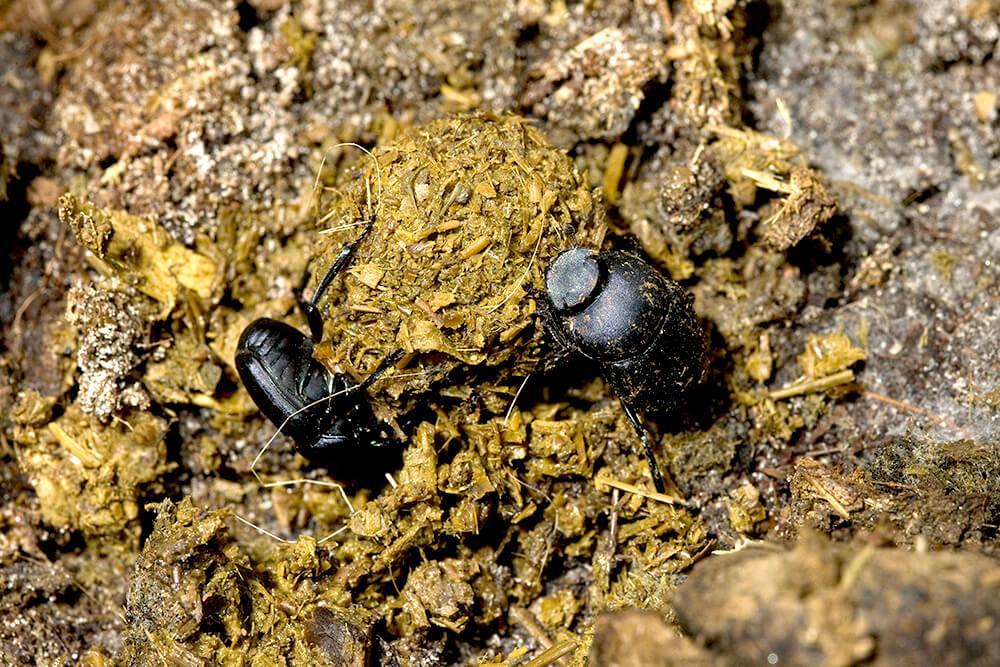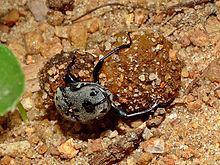The first image is the image on the left, the second image is the image on the right. Assess this claim about the two images: "There's no more than one dung beetle in the right image.". Correct or not? Answer yes or no. Yes. The first image is the image on the left, the second image is the image on the right. Evaluate the accuracy of this statement regarding the images: "Two beetles are crawling on the ground in the image on the left.". Is it true? Answer yes or no. Yes. 